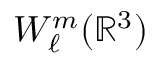Convert formula to latex. <formula><loc_0><loc_0><loc_500><loc_500>W _ { \ell } ^ { m } ( { \mathbb { R } } ^ { 3 } )</formula> 